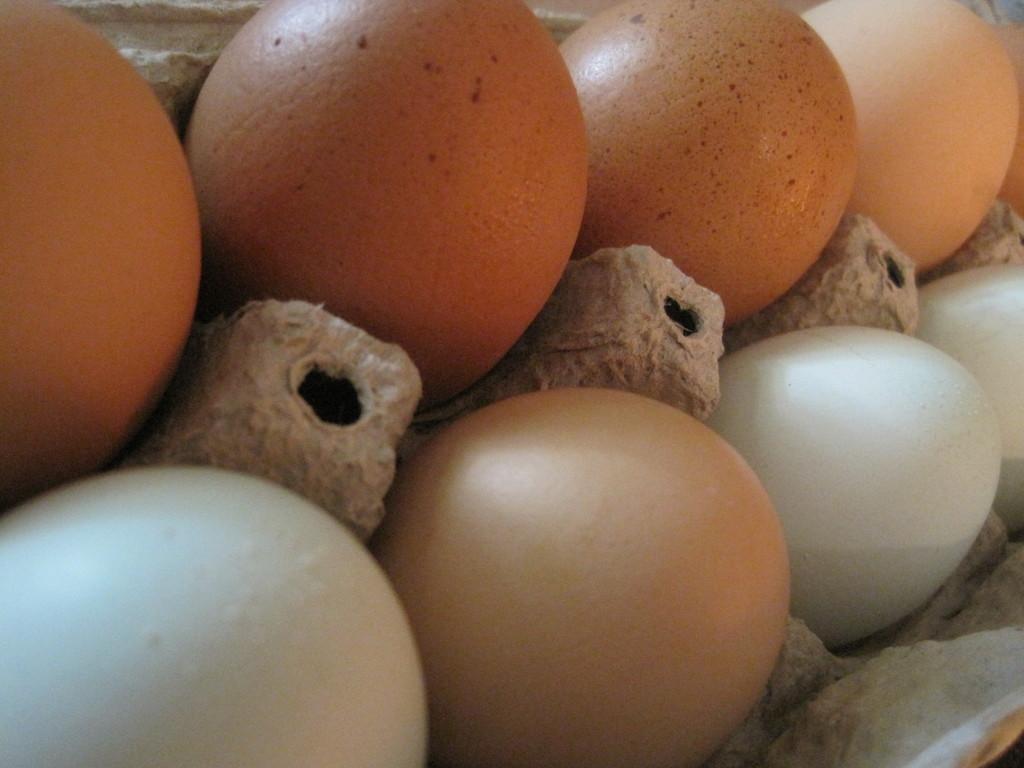How would you summarize this image in a sentence or two? In this picture there are eggs in the image. 